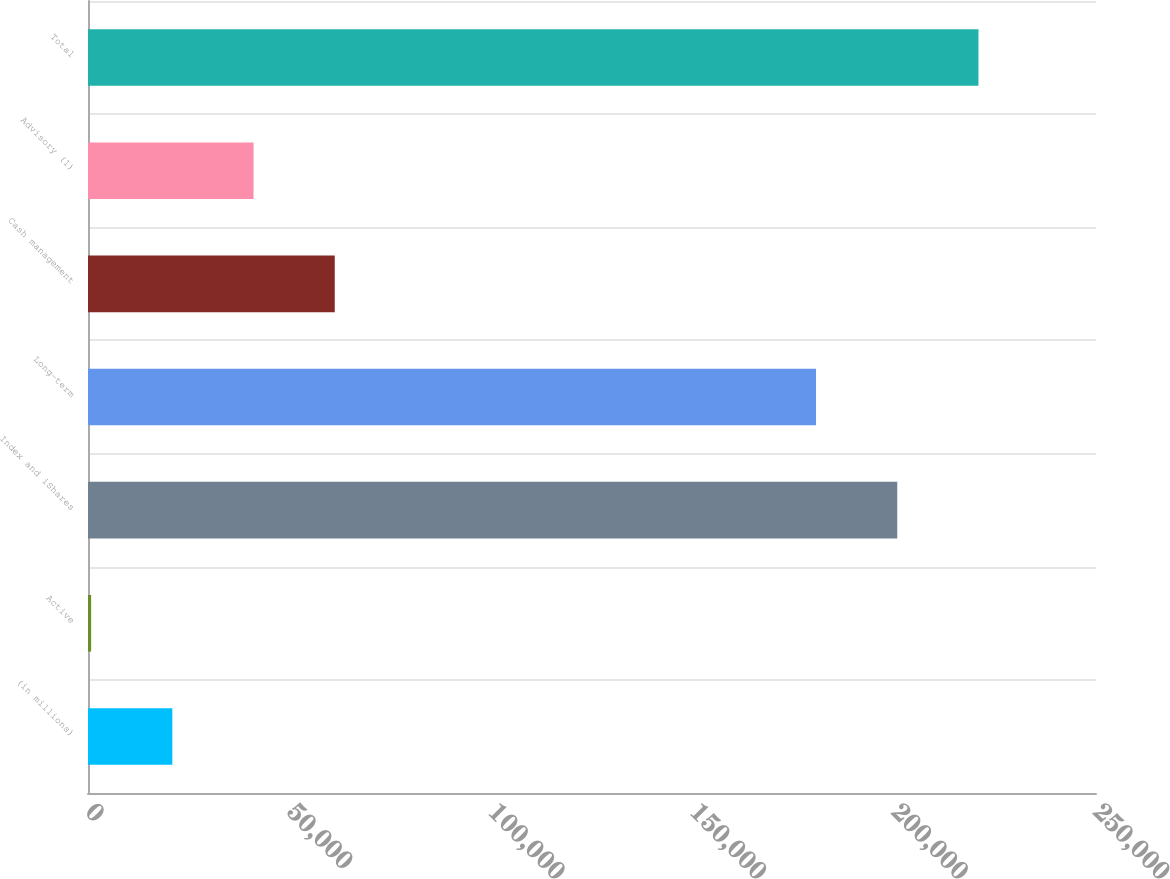<chart> <loc_0><loc_0><loc_500><loc_500><bar_chart><fcel>(in millions)<fcel>Active<fcel>Index and iShares<fcel>Long-term<fcel>Cash management<fcel>Advisory (1)<fcel>Total<nl><fcel>20915.7<fcel>774<fcel>200706<fcel>180564<fcel>61199.1<fcel>41057.4<fcel>220847<nl></chart> 